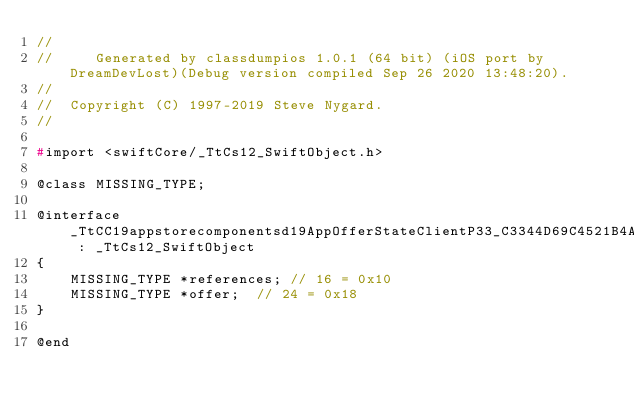<code> <loc_0><loc_0><loc_500><loc_500><_C_>//
//     Generated by classdumpios 1.0.1 (64 bit) (iOS port by DreamDevLost)(Debug version compiled Sep 26 2020 13:48:20).
//
//  Copyright (C) 1997-2019 Steve Nygard.
//

#import <swiftCore/_TtCs12_SwiftObject.h>

@class MISSING_TYPE;

@interface _TtCC19appstorecomponentsd19AppOfferStateClientP33_C3344D69C4521B4ACA82248310E985E011Observation : _TtCs12_SwiftObject
{
    MISSING_TYPE *references;	// 16 = 0x10
    MISSING_TYPE *offer;	// 24 = 0x18
}

@end

</code> 